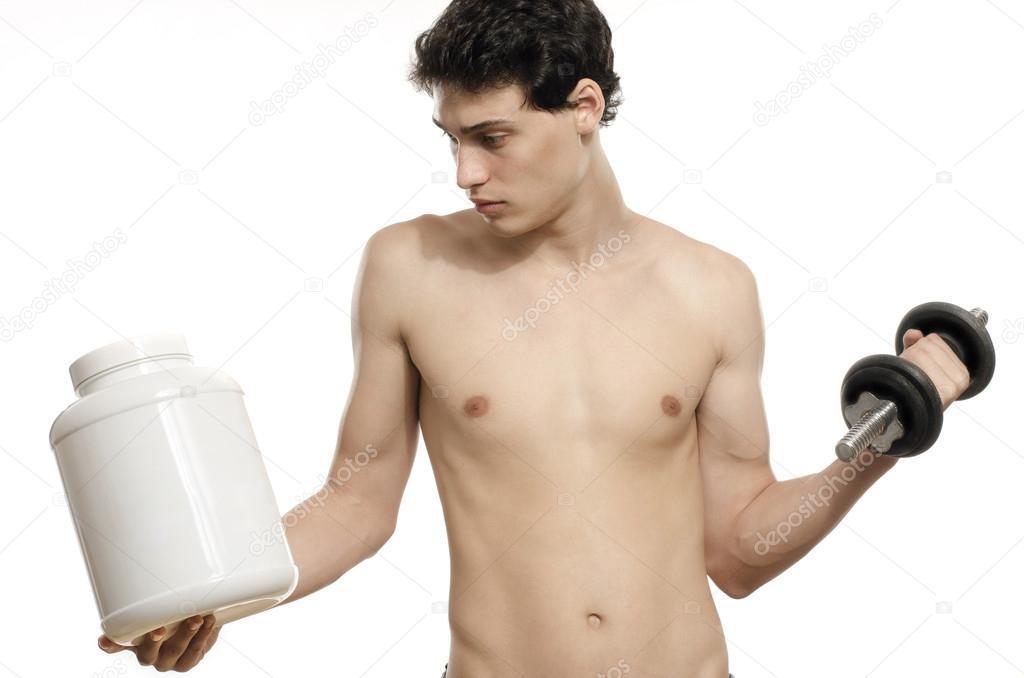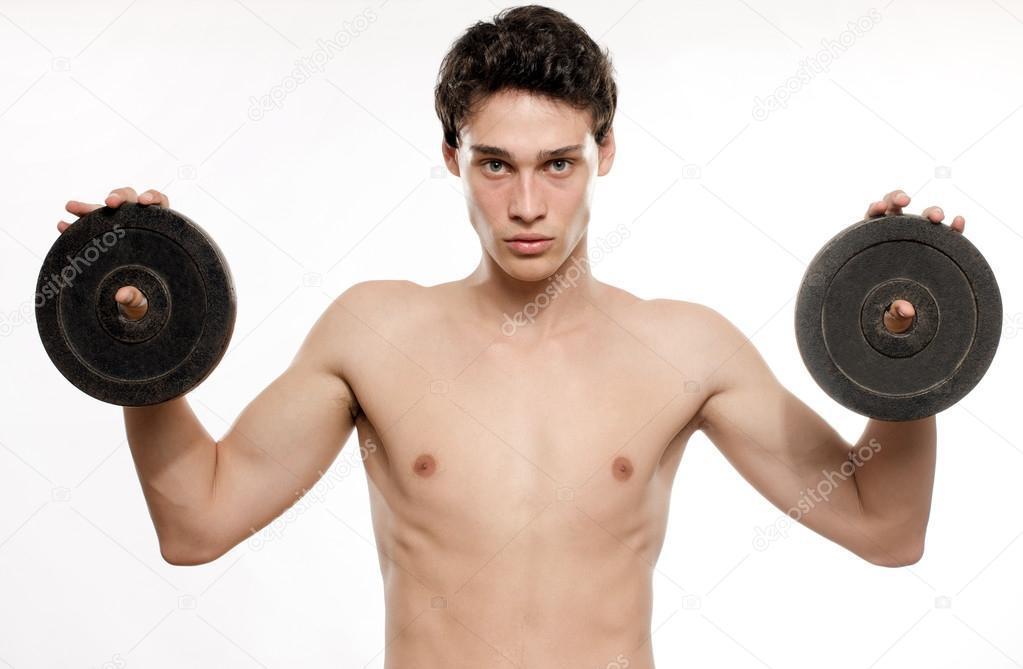The first image is the image on the left, the second image is the image on the right. Evaluate the accuracy of this statement regarding the images: "An image shows a man holding identical weights in each hand.". Is it true? Answer yes or no. Yes. 